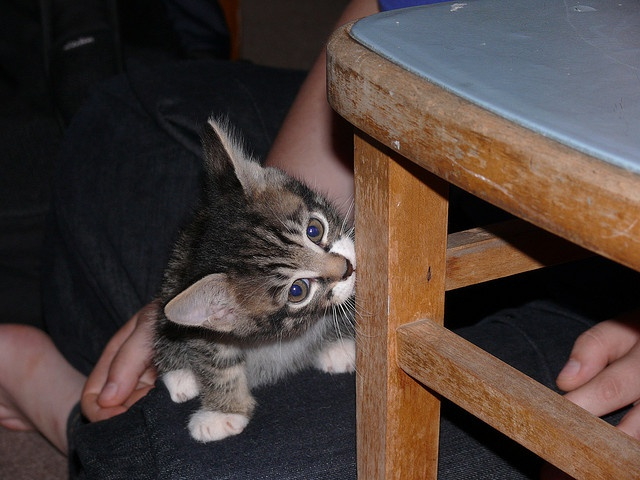Describe the objects in this image and their specific colors. I can see chair in black, gray, and brown tones, people in black, gray, brown, and maroon tones, and cat in black, gray, and darkgray tones in this image. 